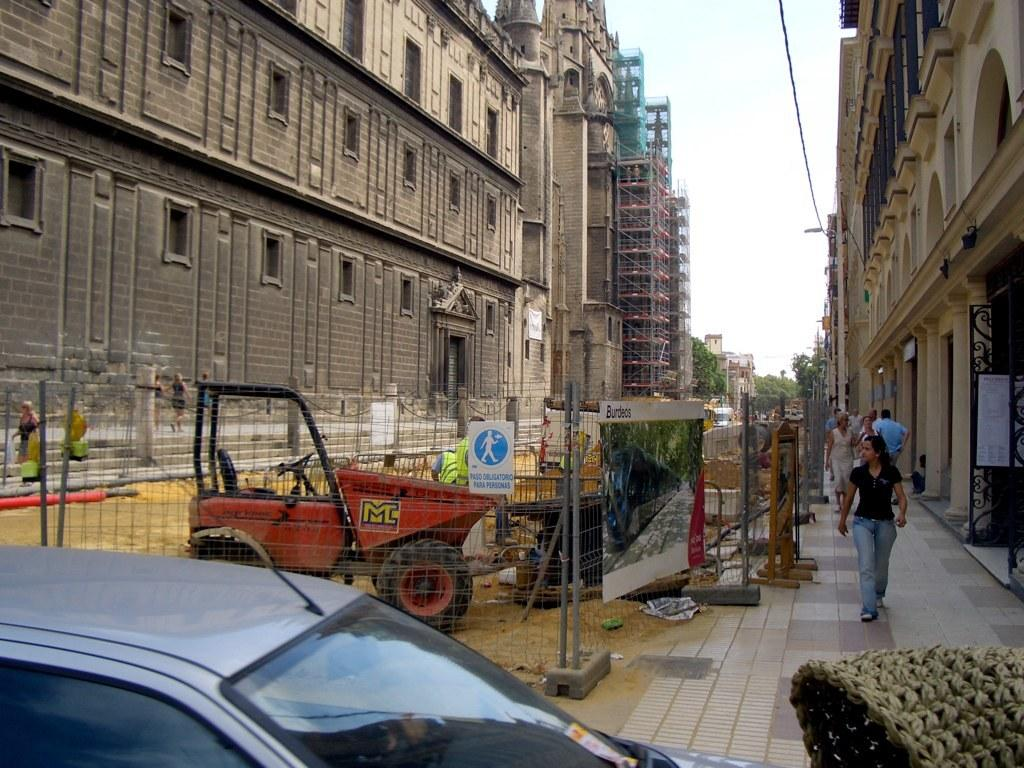What type of construction activity is taking place in the image? There are buildings under construction in the image. Are there any completed buildings in the image? Yes, there are completed buildings in the image. What can be seen moving on the road in the image? Persons walking on the road and motor vehicles are visible in the image. What type of signage is present in the image? Advertisement boards and sign boards are present in the image. What natural elements can be seen in the image? Trees are visible in the image. What infrastructure elements are present in the image? Cables and fences are present in the image. What part of the environment is visible in the image? The sky is visible in the image. How many tails can be seen on the animals in the image? There are no animals with tails present in the image. What is the distance between the completed buildings and the under-construction buildings in the image? The provided facts do not give information about the distance between the buildings, so it cannot be determined from the image. 